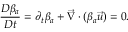<formula> <loc_0><loc_0><loc_500><loc_500>\frac { D \beta _ { a } } { D t } = \partial _ { t } \beta _ { a } + \vec { \nabla } \cdot ( \beta _ { a } \vec { u } ) = 0 .</formula> 